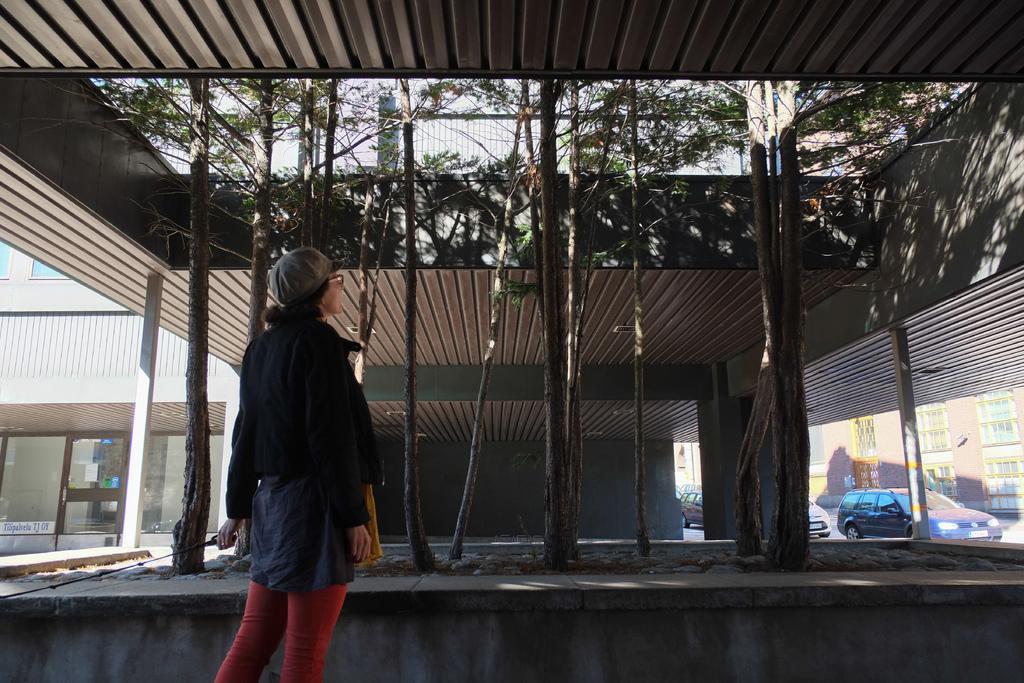Please provide a concise description of this image. In this image there is a woman standing, at the top there is a roof, in the middle there are trees, in the background there buildings and cars. 